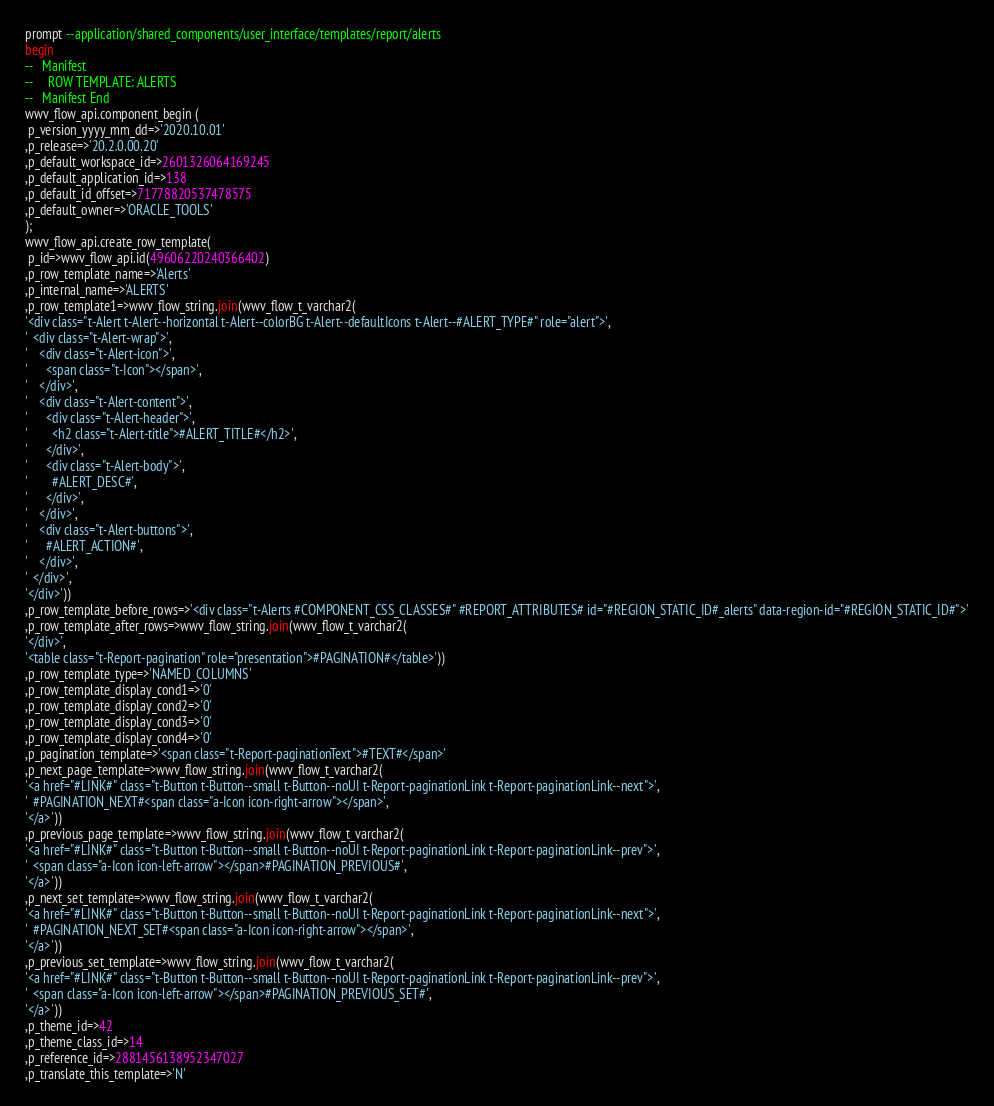Convert code to text. <code><loc_0><loc_0><loc_500><loc_500><_SQL_>prompt --application/shared_components/user_interface/templates/report/alerts
begin
--   Manifest
--     ROW TEMPLATE: ALERTS
--   Manifest End
wwv_flow_api.component_begin (
 p_version_yyyy_mm_dd=>'2020.10.01'
,p_release=>'20.2.0.00.20'
,p_default_workspace_id=>2601326064169245
,p_default_application_id=>138
,p_default_id_offset=>71778820537478575
,p_default_owner=>'ORACLE_TOOLS'
);
wwv_flow_api.create_row_template(
 p_id=>wwv_flow_api.id(49606220240366402)
,p_row_template_name=>'Alerts'
,p_internal_name=>'ALERTS'
,p_row_template1=>wwv_flow_string.join(wwv_flow_t_varchar2(
'<div class="t-Alert t-Alert--horizontal t-Alert--colorBG t-Alert--defaultIcons t-Alert--#ALERT_TYPE#" role="alert">',
'  <div class="t-Alert-wrap">',
'    <div class="t-Alert-icon">',
'      <span class="t-Icon"></span>',
'    </div>',
'    <div class="t-Alert-content">',
'      <div class="t-Alert-header">',
'        <h2 class="t-Alert-title">#ALERT_TITLE#</h2>',
'      </div>',
'      <div class="t-Alert-body">',
'        #ALERT_DESC#',
'      </div>',
'    </div>',
'    <div class="t-Alert-buttons">',
'      #ALERT_ACTION#',
'    </div>',
'  </div>',
'</div>'))
,p_row_template_before_rows=>'<div class="t-Alerts #COMPONENT_CSS_CLASSES#" #REPORT_ATTRIBUTES# id="#REGION_STATIC_ID#_alerts" data-region-id="#REGION_STATIC_ID#">'
,p_row_template_after_rows=>wwv_flow_string.join(wwv_flow_t_varchar2(
'</div>',
'<table class="t-Report-pagination" role="presentation">#PAGINATION#</table>'))
,p_row_template_type=>'NAMED_COLUMNS'
,p_row_template_display_cond1=>'0'
,p_row_template_display_cond2=>'0'
,p_row_template_display_cond3=>'0'
,p_row_template_display_cond4=>'0'
,p_pagination_template=>'<span class="t-Report-paginationText">#TEXT#</span>'
,p_next_page_template=>wwv_flow_string.join(wwv_flow_t_varchar2(
'<a href="#LINK#" class="t-Button t-Button--small t-Button--noUI t-Report-paginationLink t-Report-paginationLink--next">',
'  #PAGINATION_NEXT#<span class="a-Icon icon-right-arrow"></span>',
'</a>'))
,p_previous_page_template=>wwv_flow_string.join(wwv_flow_t_varchar2(
'<a href="#LINK#" class="t-Button t-Button--small t-Button--noUI t-Report-paginationLink t-Report-paginationLink--prev">',
'  <span class="a-Icon icon-left-arrow"></span>#PAGINATION_PREVIOUS#',
'</a>'))
,p_next_set_template=>wwv_flow_string.join(wwv_flow_t_varchar2(
'<a href="#LINK#" class="t-Button t-Button--small t-Button--noUI t-Report-paginationLink t-Report-paginationLink--next">',
'  #PAGINATION_NEXT_SET#<span class="a-Icon icon-right-arrow"></span>',
'</a>'))
,p_previous_set_template=>wwv_flow_string.join(wwv_flow_t_varchar2(
'<a href="#LINK#" class="t-Button t-Button--small t-Button--noUI t-Report-paginationLink t-Report-paginationLink--prev">',
'  <span class="a-Icon icon-left-arrow"></span>#PAGINATION_PREVIOUS_SET#',
'</a>'))
,p_theme_id=>42
,p_theme_class_id=>14
,p_reference_id=>2881456138952347027
,p_translate_this_template=>'N'</code> 